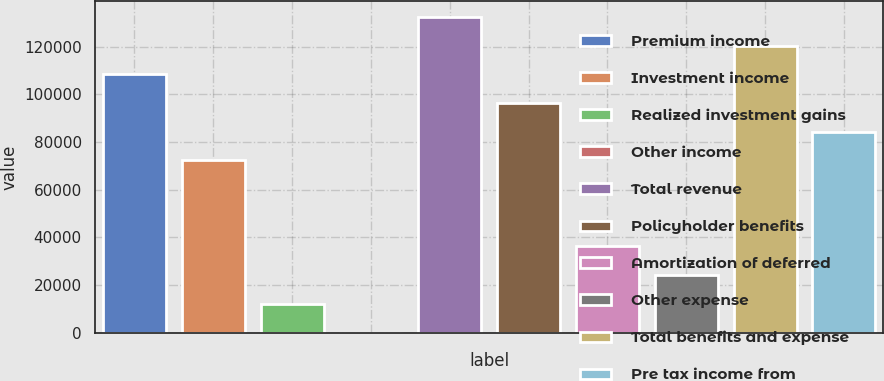<chart> <loc_0><loc_0><loc_500><loc_500><bar_chart><fcel>Premium income<fcel>Investment income<fcel>Realized investment gains<fcel>Other income<fcel>Total revenue<fcel>Policyholder benefits<fcel>Amortization of deferred<fcel>Other expense<fcel>Total benefits and expense<fcel>Pre tax income from<nl><fcel>108384<fcel>72290.2<fcel>12134.2<fcel>103<fcel>132446<fcel>96352.6<fcel>36196.6<fcel>24165.4<fcel>120415<fcel>84321.4<nl></chart> 